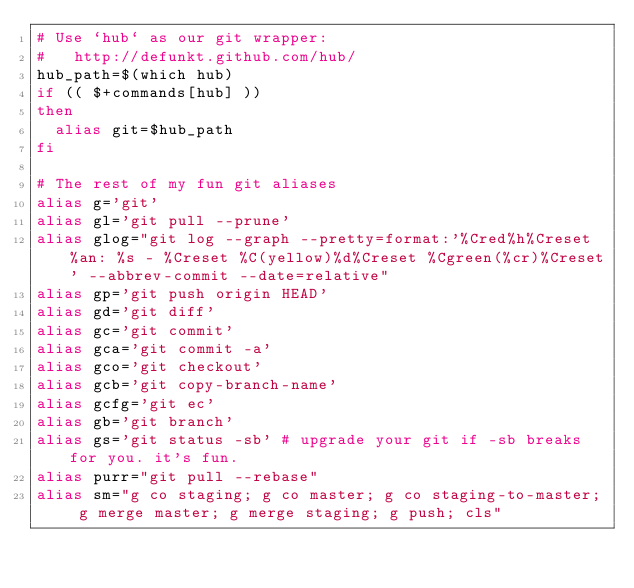<code> <loc_0><loc_0><loc_500><loc_500><_Bash_># Use `hub` as our git wrapper:
#   http://defunkt.github.com/hub/
hub_path=$(which hub)
if (( $+commands[hub] ))
then
  alias git=$hub_path
fi

# The rest of my fun git aliases
alias g='git'
alias gl='git pull --prune'
alias glog="git log --graph --pretty=format:'%Cred%h%Creset %an: %s - %Creset %C(yellow)%d%Creset %Cgreen(%cr)%Creset' --abbrev-commit --date=relative"
alias gp='git push origin HEAD'
alias gd='git diff'
alias gc='git commit'
alias gca='git commit -a'
alias gco='git checkout'
alias gcb='git copy-branch-name'
alias gcfg='git ec'
alias gb='git branch'
alias gs='git status -sb' # upgrade your git if -sb breaks for you. it's fun.
alias purr="git pull --rebase"
alias sm="g co staging; g co master; g co staging-to-master; g merge master; g merge staging; g push; cls"</code> 